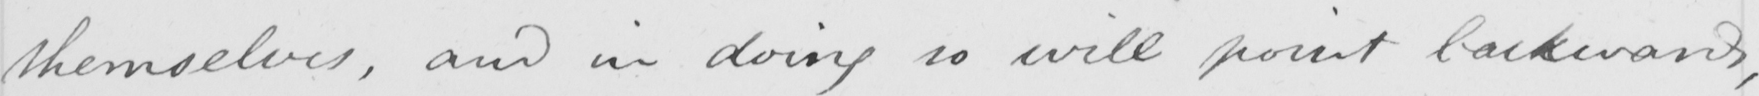What text is written in this handwritten line? themselves  , and in doing so will point backwards , 